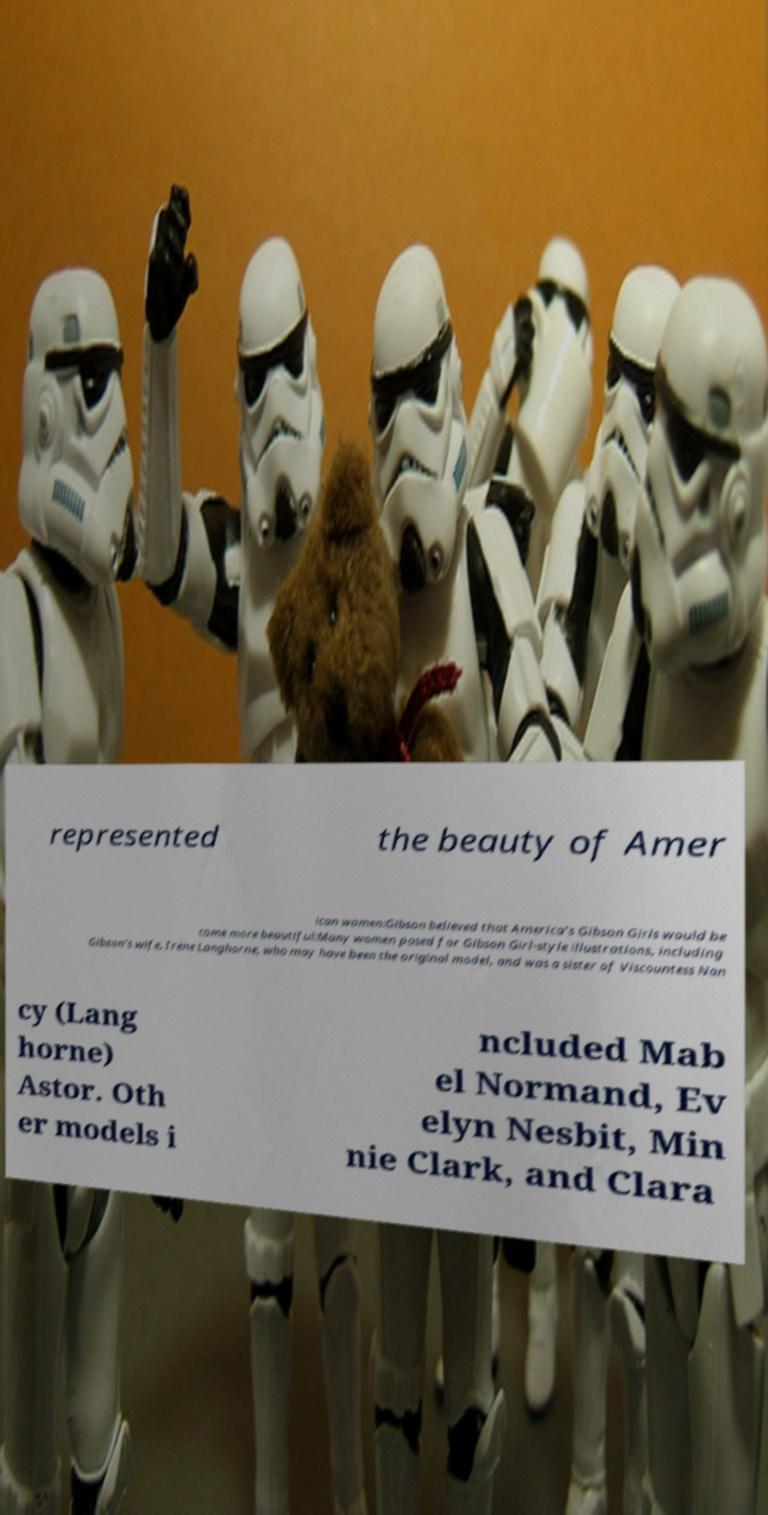What messages or text are displayed in this image? I need them in a readable, typed format. represented the beauty of Amer ican women:Gibson believed that America's Gibson Girls would be come more beautiful:Many women posed for Gibson Girl-style illustrations, including Gibson's wife, Irene Langhorne, who may have been the original model, and was a sister of Viscountess Nan cy (Lang horne) Astor. Oth er models i ncluded Mab el Normand, Ev elyn Nesbit, Min nie Clark, and Clara 